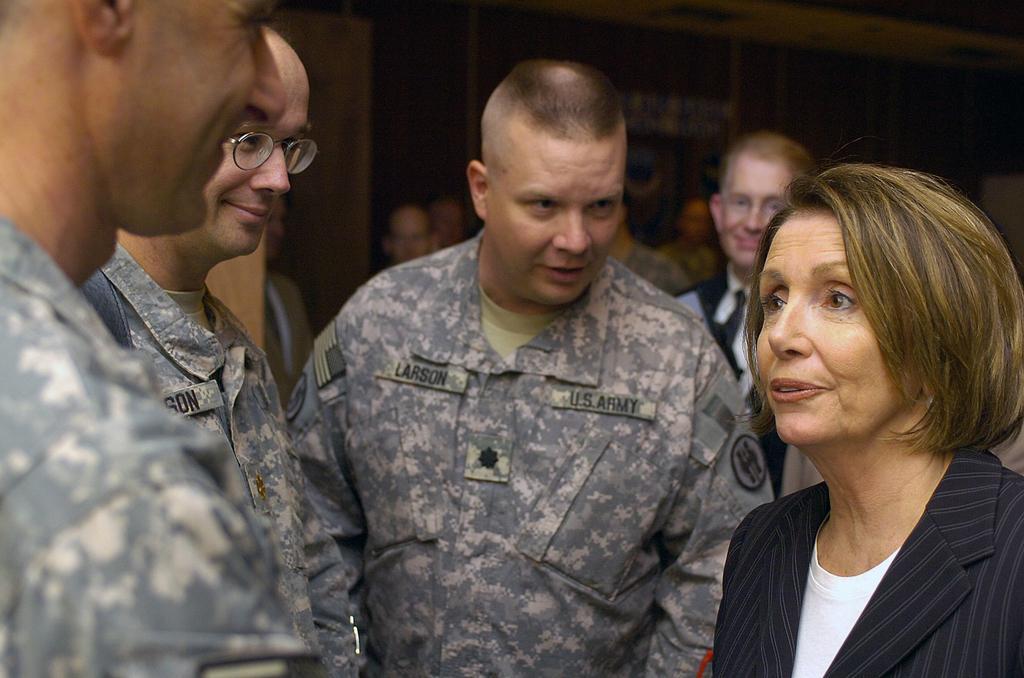Please provide a concise description of this image. In this image we can see people interacting with each other. 